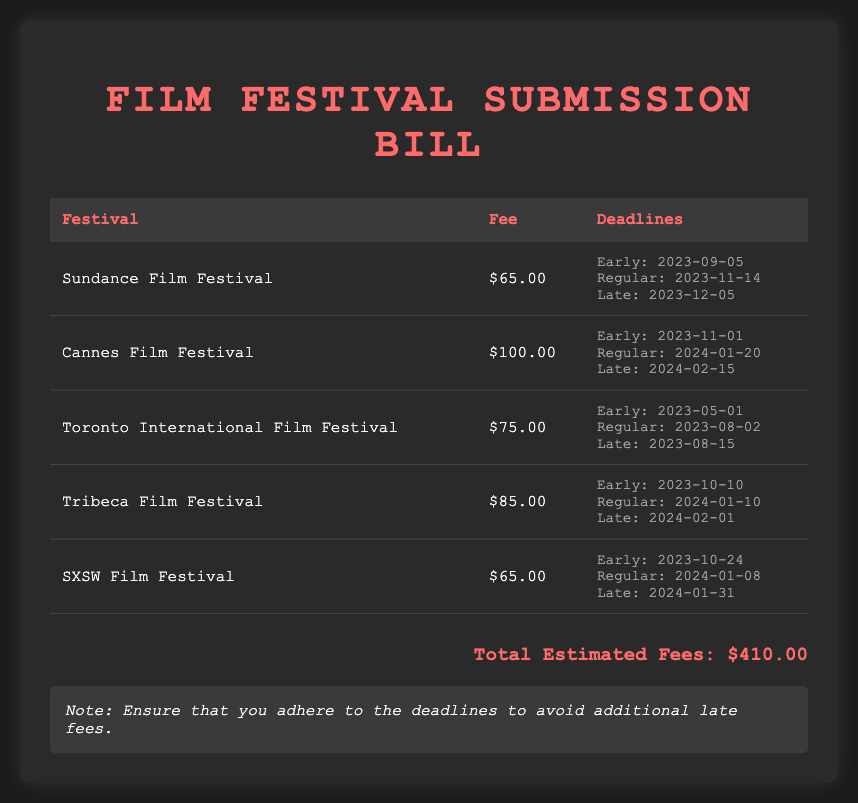What is the fee for Sundance Film Festival? The fee for Sundance Film Festival is stated in the document as $65.00.
Answer: $65.00 What is theTotal Estimated Fees? The Total Estimated Fees is a summary located at the end of the document, which amounts to $410.00.
Answer: $410.00 When is the late deadline for Cannes Film Festival? The late deadline for Cannes Film Festival is specified as 2024-02-15.
Answer: 2024-02-15 How much does it cost to submit to the Toronto International Film Festival? The cost for submission to the Toronto International Film Festival is mentioned as $75.00.
Answer: $75.00 What is the early deadline for SXSW Film Festival? The early deadline for SXSW Film Festival is provided as 2023-10-24.
Answer: 2023-10-24 Which festival has the highest submission fee? The document lists Cannes Film Festival as having the highest submission fee at $100.00.
Answer: Cannes Film Festival What is the total number of festivals listed in the document? The total number of festivals mentioned is counted within the document, giving a total of five festivals.
Answer: Five What important note is provided at the end of the document? The important note at the end of the document advises adherence to deadlines to avoid additional late fees.
Answer: Ensure that you adhere to the deadlines to avoid additional late fees 